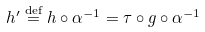Convert formula to latex. <formula><loc_0><loc_0><loc_500><loc_500>h ^ { \prime } \overset { \text {def} } { = } h \circ \alpha ^ { - 1 } = \tau \circ g \circ \alpha ^ { - 1 }</formula> 